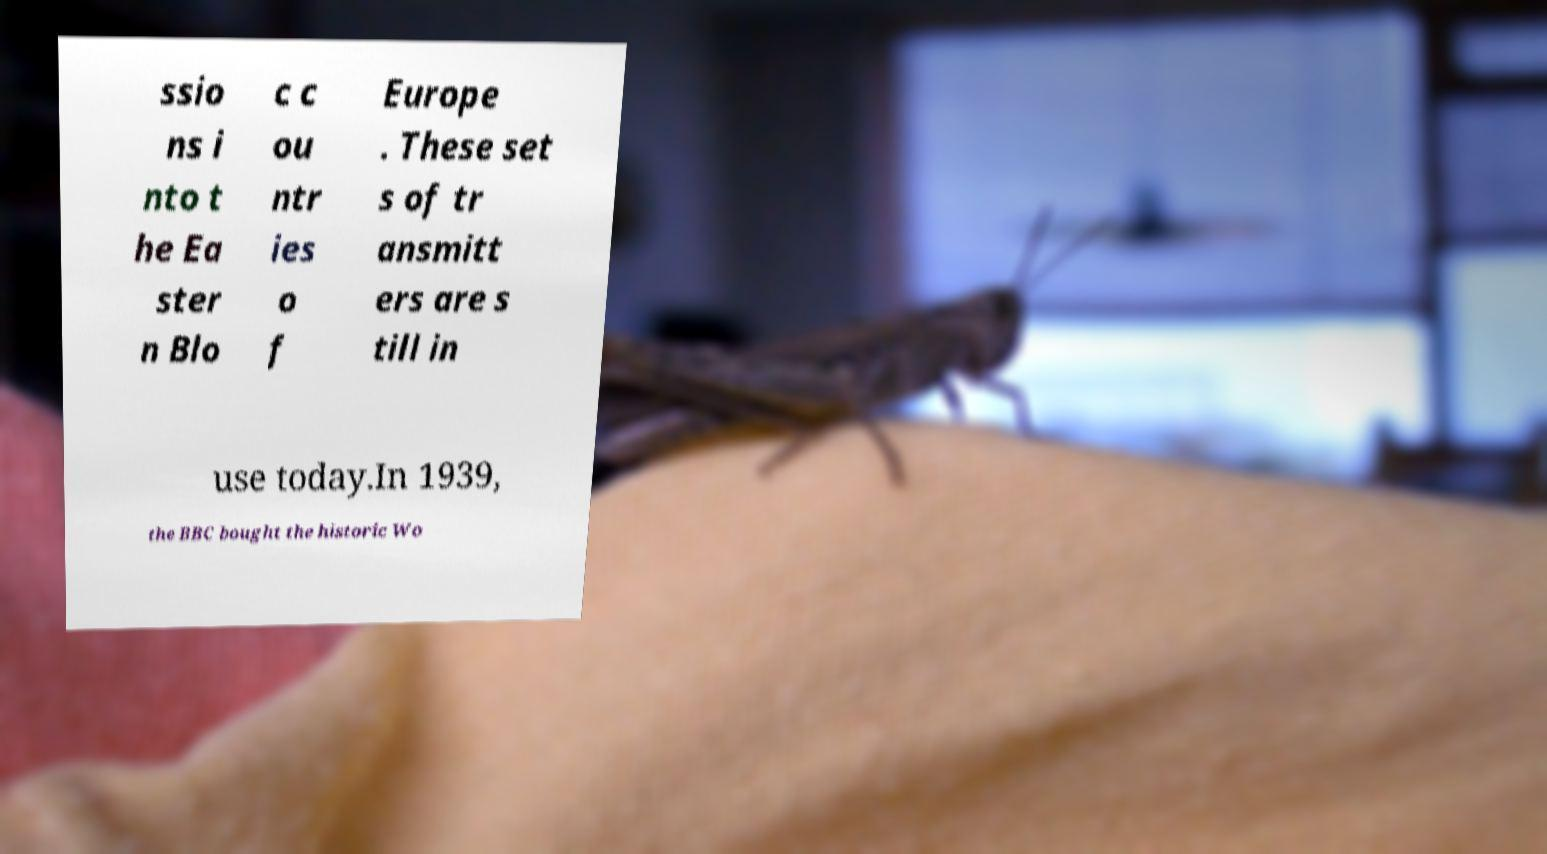Could you assist in decoding the text presented in this image and type it out clearly? ssio ns i nto t he Ea ster n Blo c c ou ntr ies o f Europe . These set s of tr ansmitt ers are s till in use today.In 1939, the BBC bought the historic Wo 